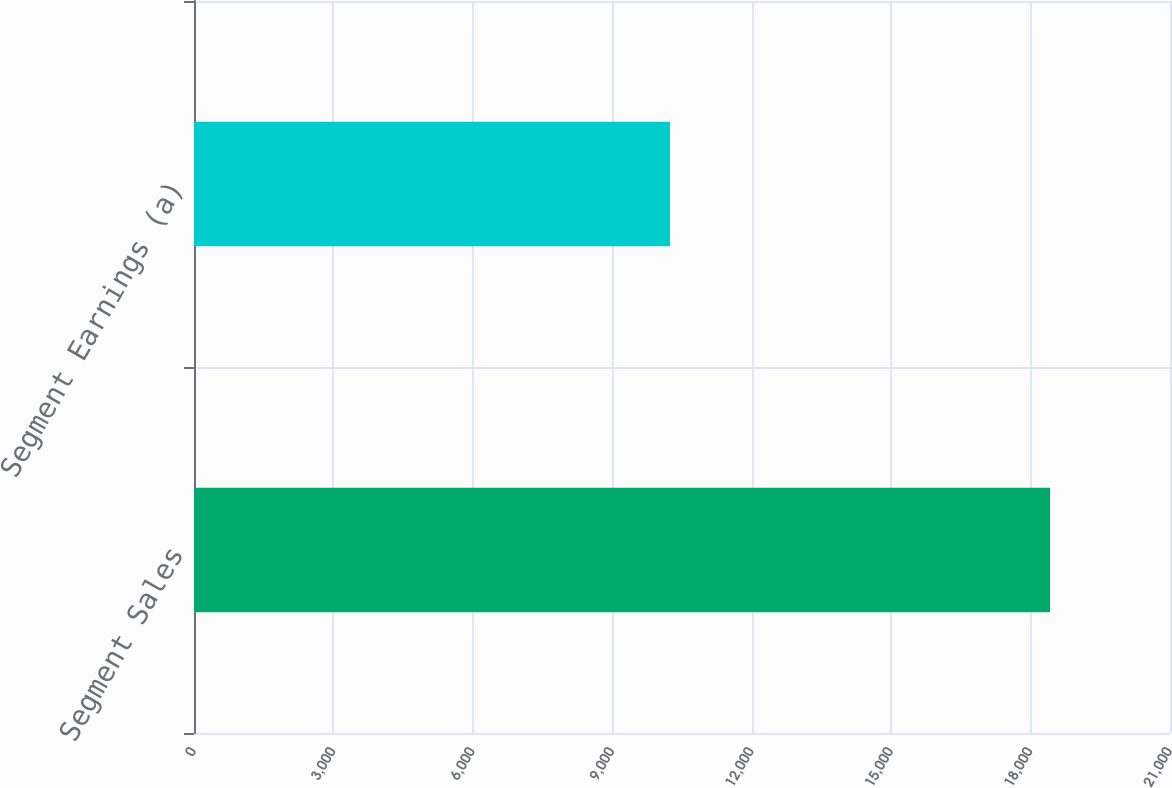Convert chart to OTSL. <chart><loc_0><loc_0><loc_500><loc_500><bar_chart><fcel>Segment Sales<fcel>Segment Earnings (a)<nl><fcel>18419<fcel>10241<nl></chart> 